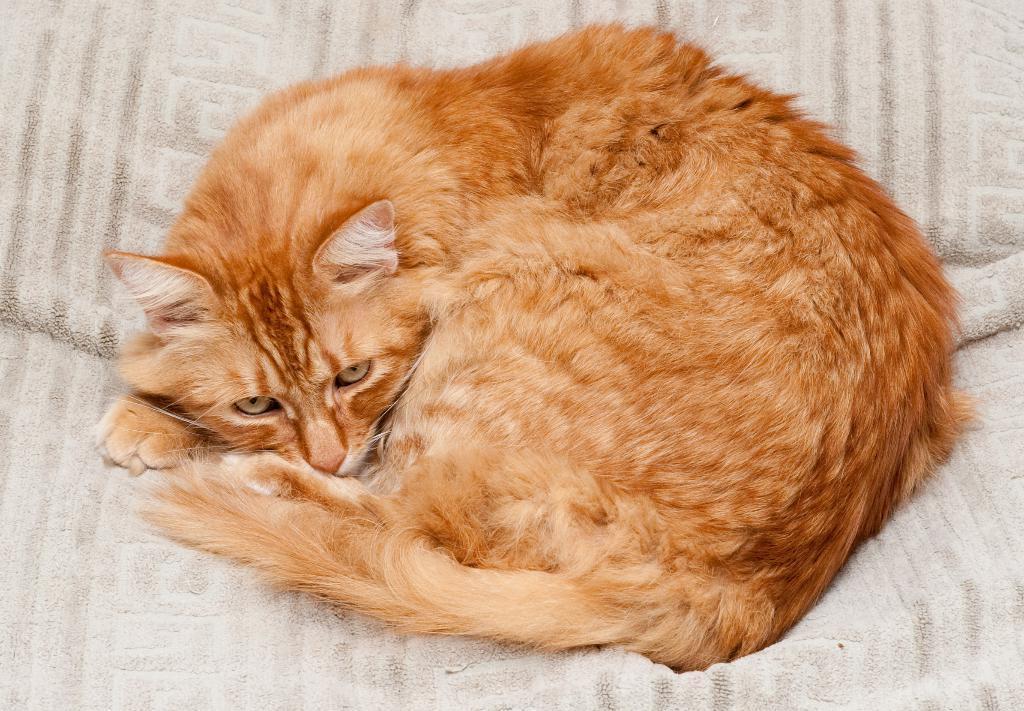Could you give a brief overview of what you see in this image? In this image we can see a cat is sitting on the white color surface. 